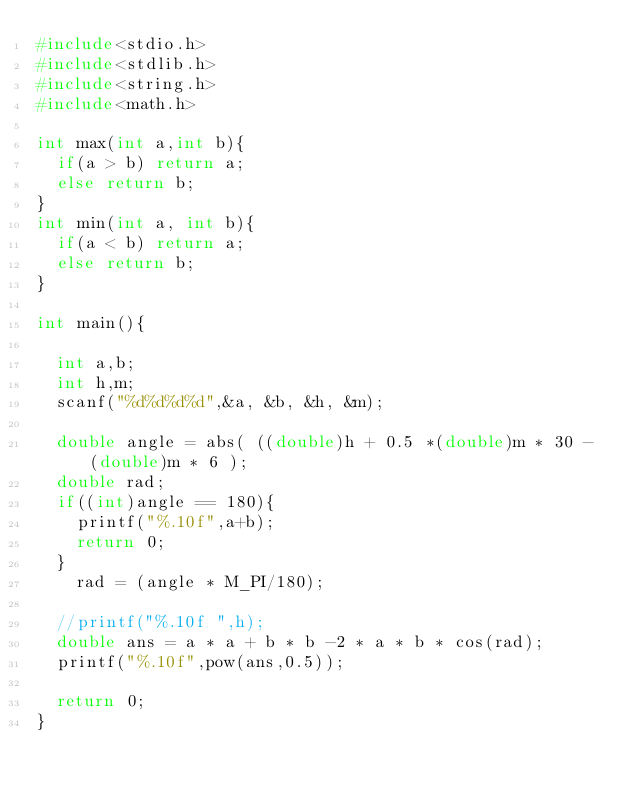Convert code to text. <code><loc_0><loc_0><loc_500><loc_500><_C_>#include<stdio.h>
#include<stdlib.h>
#include<string.h>
#include<math.h>

int max(int a,int b){
  if(a > b) return a;
  else return b;
}
int min(int a, int b){
  if(a < b) return a;
  else return b;
}

int main(){

  int a,b;
  int h,m;
  scanf("%d%d%d%d",&a, &b, &h, &m);

  double angle = abs( ((double)h + 0.5 *(double)m * 30 - (double)m * 6 );
  double rad;
  if((int)angle == 180){
    printf("%.10f",a+b);
    return 0;
  }
    rad = (angle * M_PI/180);

  //printf("%.10f ",h);
  double ans = a * a + b * b -2 * a * b * cos(rad);
  printf("%.10f",pow(ans,0.5));

  return 0;
}
</code> 